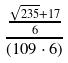Convert formula to latex. <formula><loc_0><loc_0><loc_500><loc_500>\frac { \frac { \sqrt { 2 3 5 } + 1 7 } { 6 } } { ( 1 0 9 \cdot 6 ) }</formula> 